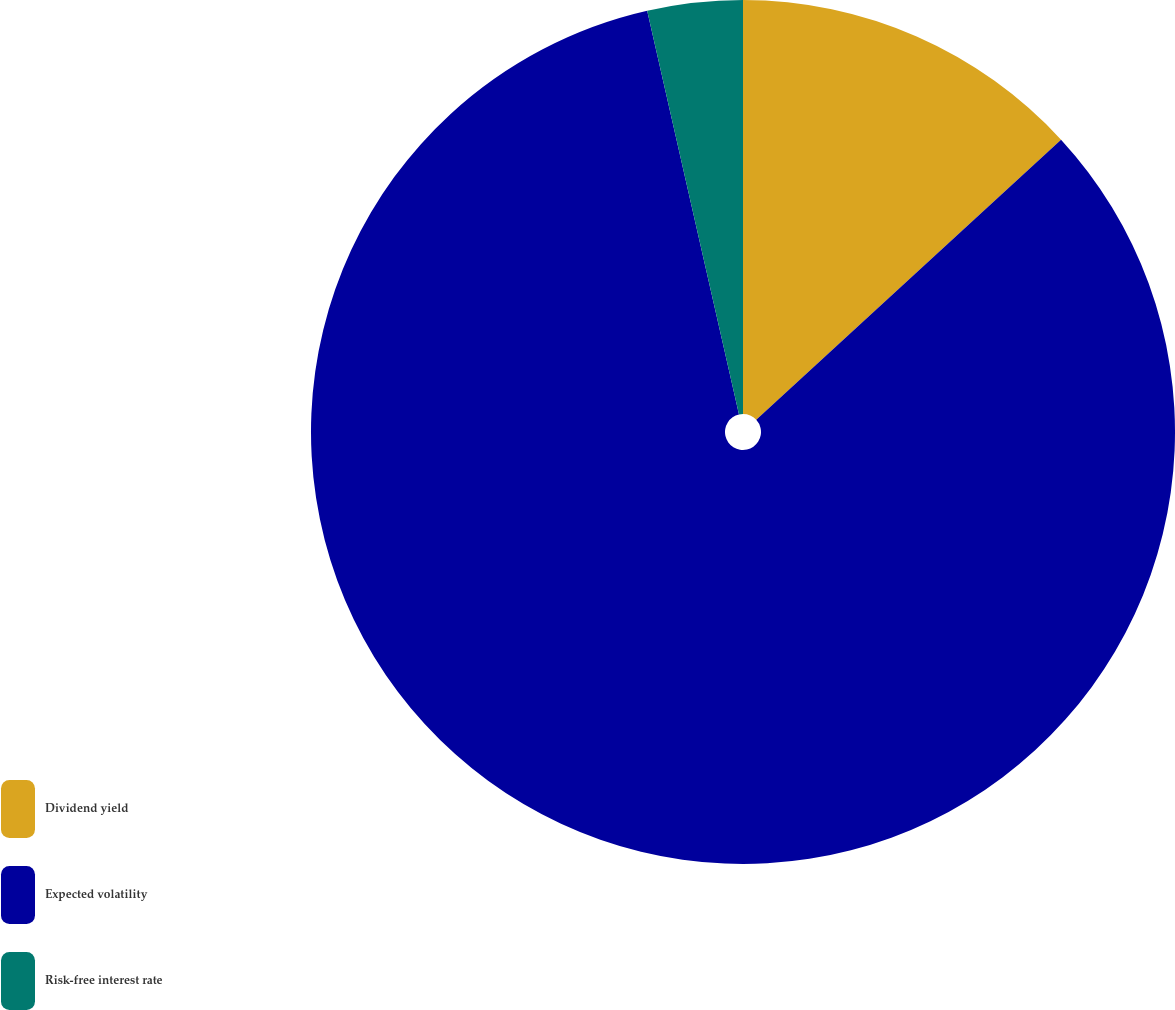<chart> <loc_0><loc_0><loc_500><loc_500><pie_chart><fcel>Dividend yield<fcel>Expected volatility<fcel>Risk-free interest rate<nl><fcel>13.17%<fcel>83.27%<fcel>3.56%<nl></chart> 